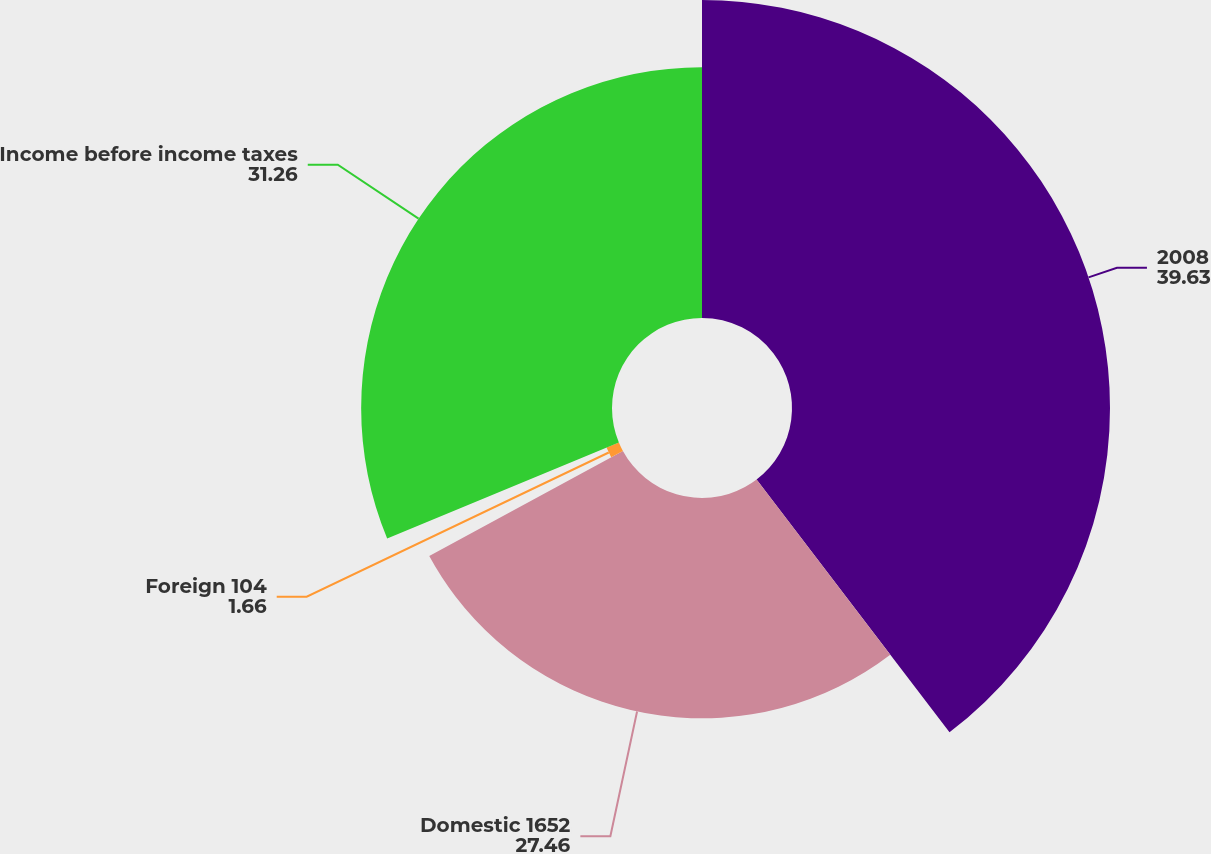<chart> <loc_0><loc_0><loc_500><loc_500><pie_chart><fcel>2008<fcel>Domestic 1652<fcel>Foreign 104<fcel>Income before income taxes<nl><fcel>39.63%<fcel>27.46%<fcel>1.66%<fcel>31.26%<nl></chart> 